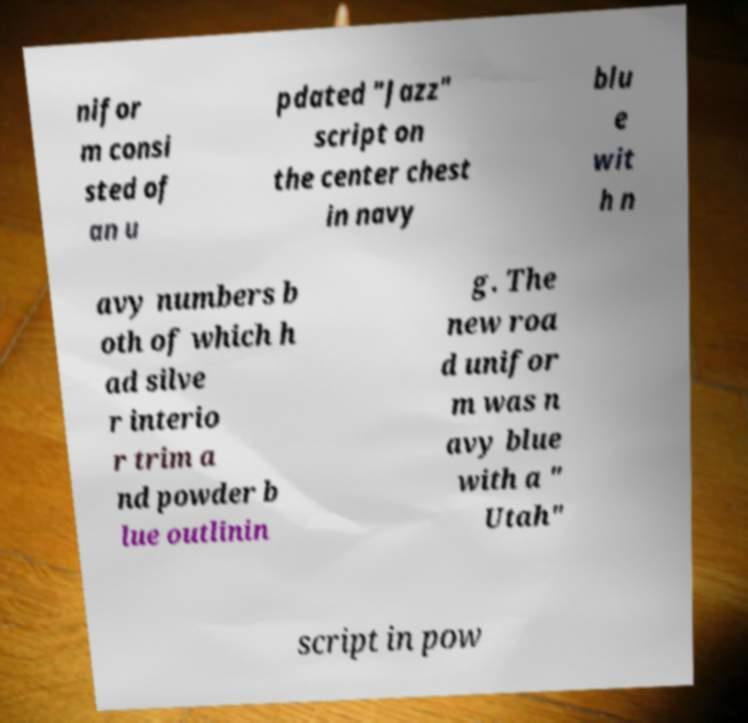Please identify and transcribe the text found in this image. nifor m consi sted of an u pdated "Jazz" script on the center chest in navy blu e wit h n avy numbers b oth of which h ad silve r interio r trim a nd powder b lue outlinin g. The new roa d unifor m was n avy blue with a " Utah" script in pow 